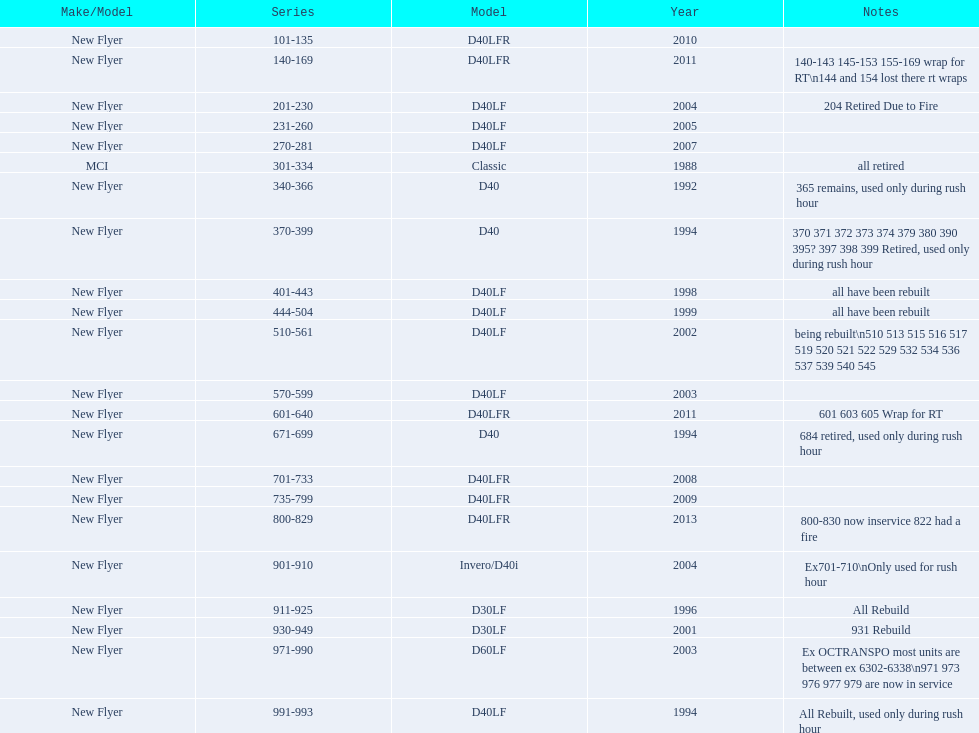What are all the series of buses? 101-135, 140-169, 201-230, 231-260, 270-281, 301-334, 340-366, 370-399, 401-443, 444-504, 510-561, 570-599, 601-640, 671-699, 701-733, 735-799, 800-829, 901-910, 911-925, 930-949, 971-990, 991-993. Which are the newest? 800-829. 